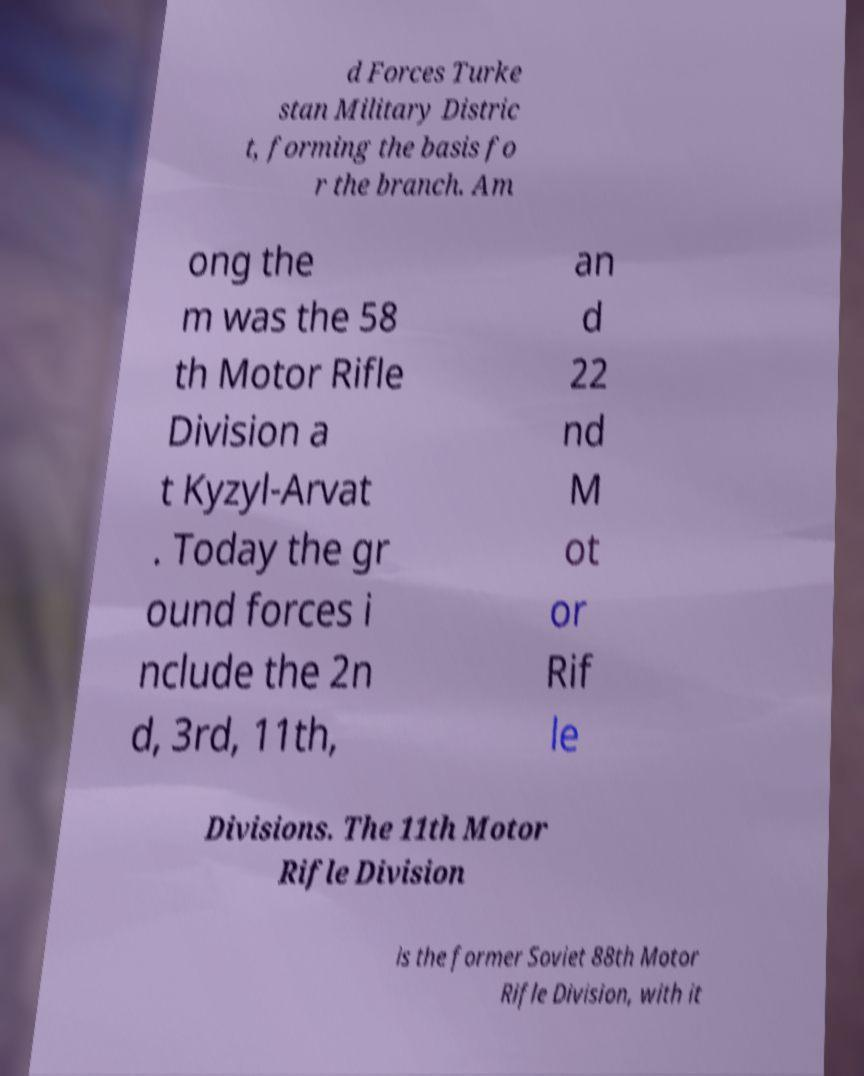Please read and relay the text visible in this image. What does it say? d Forces Turke stan Military Distric t, forming the basis fo r the branch. Am ong the m was the 58 th Motor Rifle Division a t Kyzyl-Arvat . Today the gr ound forces i nclude the 2n d, 3rd, 11th, an d 22 nd M ot or Rif le Divisions. The 11th Motor Rifle Division is the former Soviet 88th Motor Rifle Division, with it 